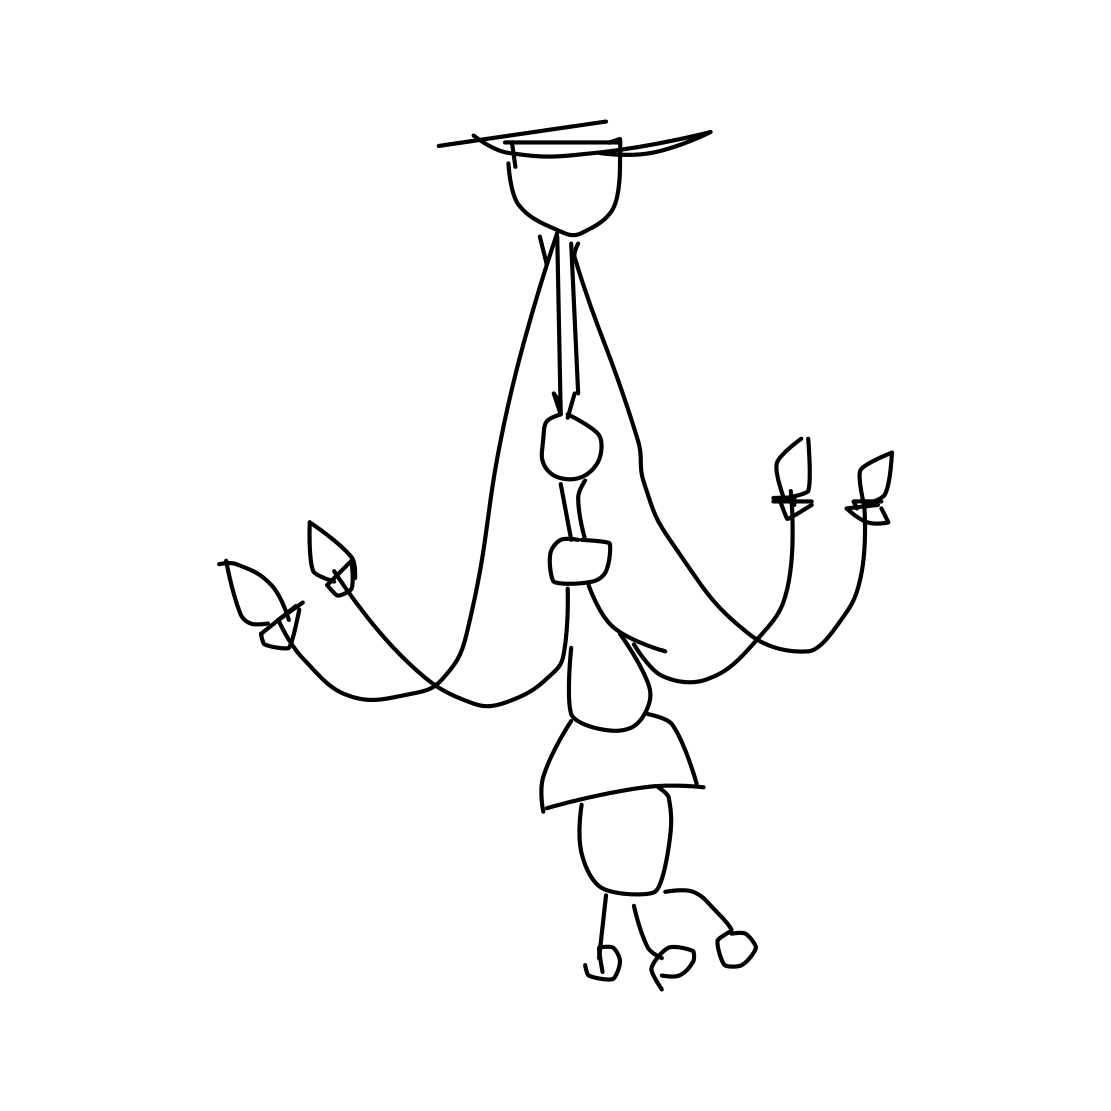Is there a sketchy diamond in the picture? There isn't a sketchy diamond present in the image, instead, what we see is a minimalist line drawing of a chandelier with several elegant curves and hanging elements that resemble candle holders. 